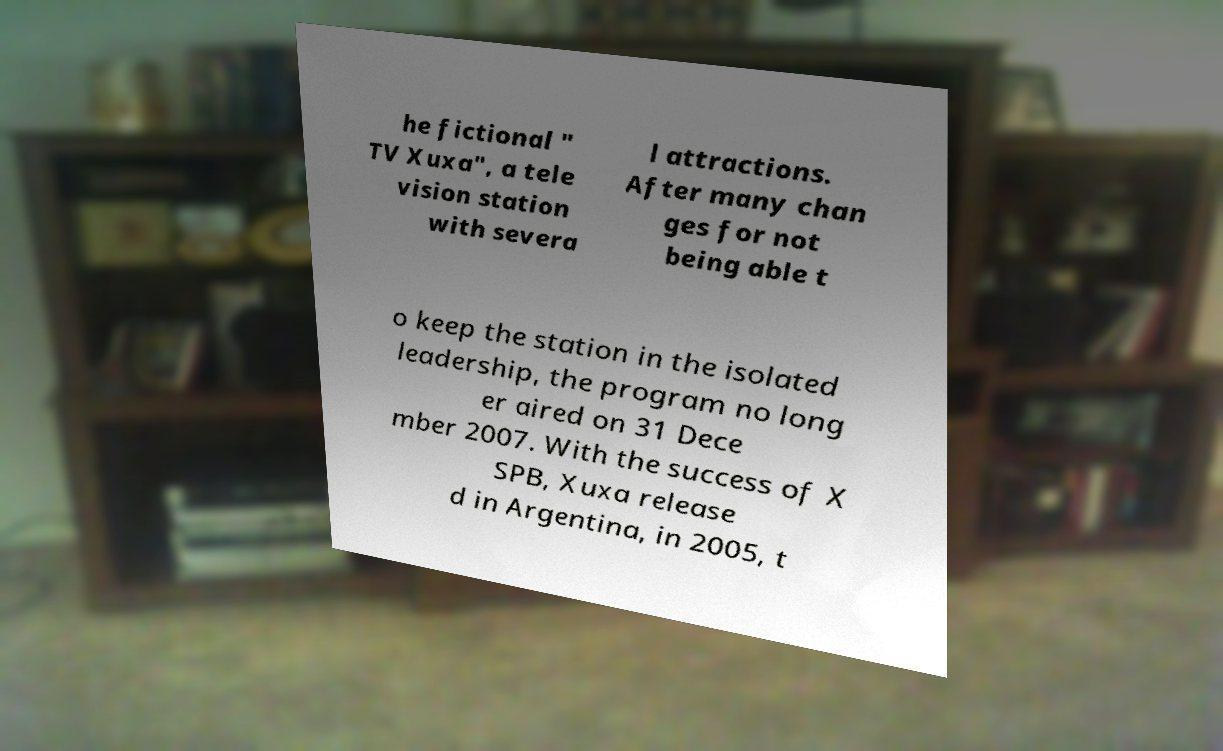For documentation purposes, I need the text within this image transcribed. Could you provide that? he fictional " TV Xuxa", a tele vision station with severa l attractions. After many chan ges for not being able t o keep the station in the isolated leadership, the program no long er aired on 31 Dece mber 2007. With the success of X SPB, Xuxa release d in Argentina, in 2005, t 